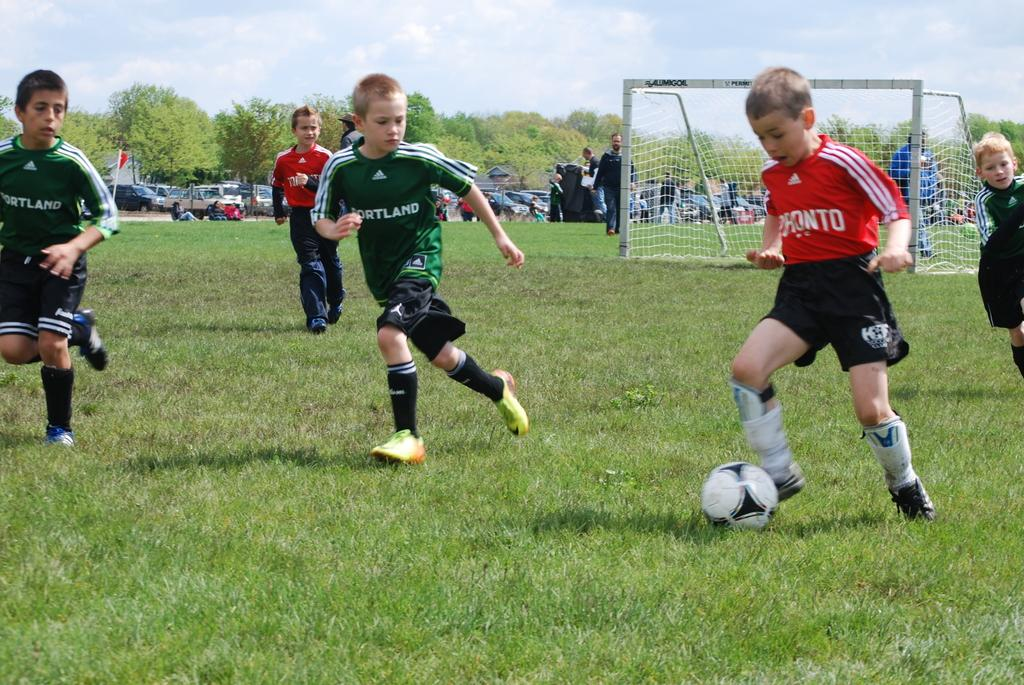<image>
Provide a brief description of the given image. a few kids playing soccer with a couple wearing Portland jerseys 